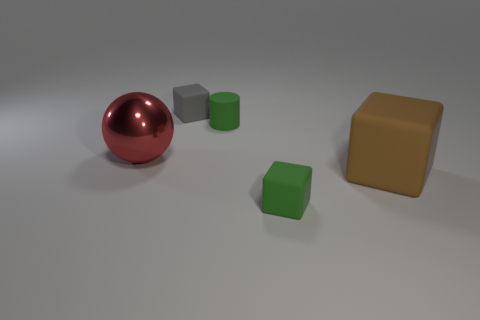Add 2 gray things. How many objects exist? 7 Subtract all cubes. How many objects are left? 2 Subtract 0 yellow blocks. How many objects are left? 5 Subtract all tiny yellow blocks. Subtract all brown matte objects. How many objects are left? 4 Add 3 tiny matte cylinders. How many tiny matte cylinders are left? 4 Add 2 green blocks. How many green blocks exist? 3 